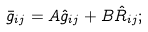Convert formula to latex. <formula><loc_0><loc_0><loc_500><loc_500>\bar { g } _ { i j } = A \hat { g } _ { i j } + B \hat { R } _ { i j } ;</formula> 